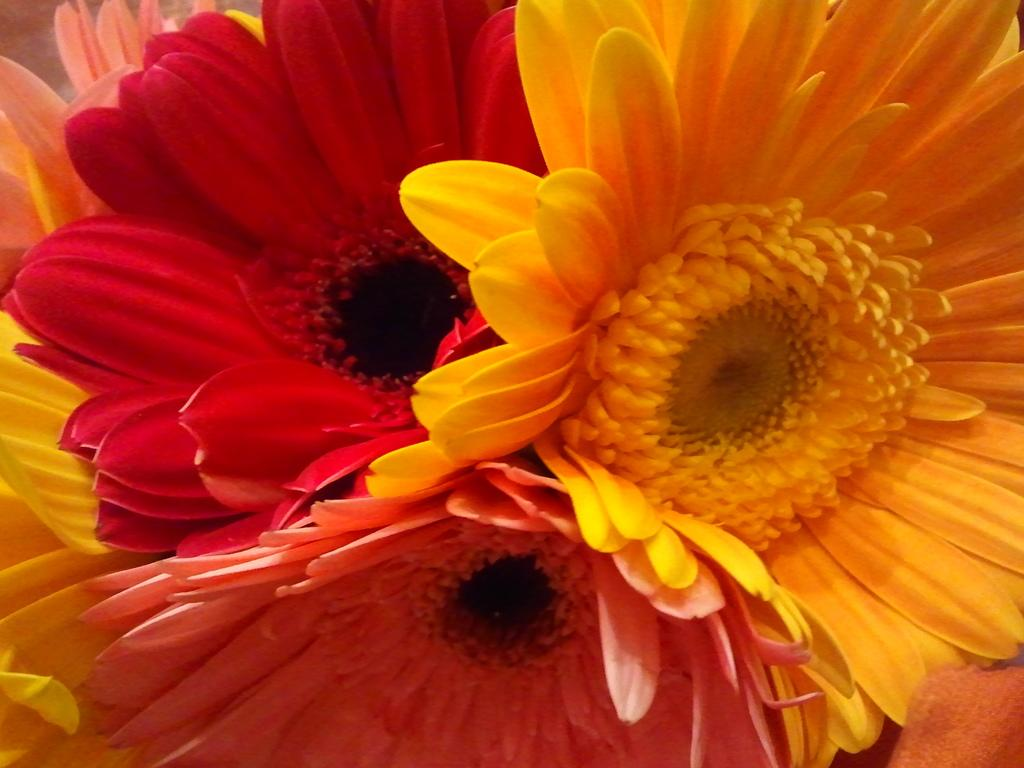What type of living organisms can be seen in the image? Flowers are visible in the image. What type of gold object is visible in the image? There is no gold object present in the image; it only features flowers. Can you describe how the ants are pushing the flowers in the image? There are no ants present in the image, and therefore no pushing of flowers can be observed. 